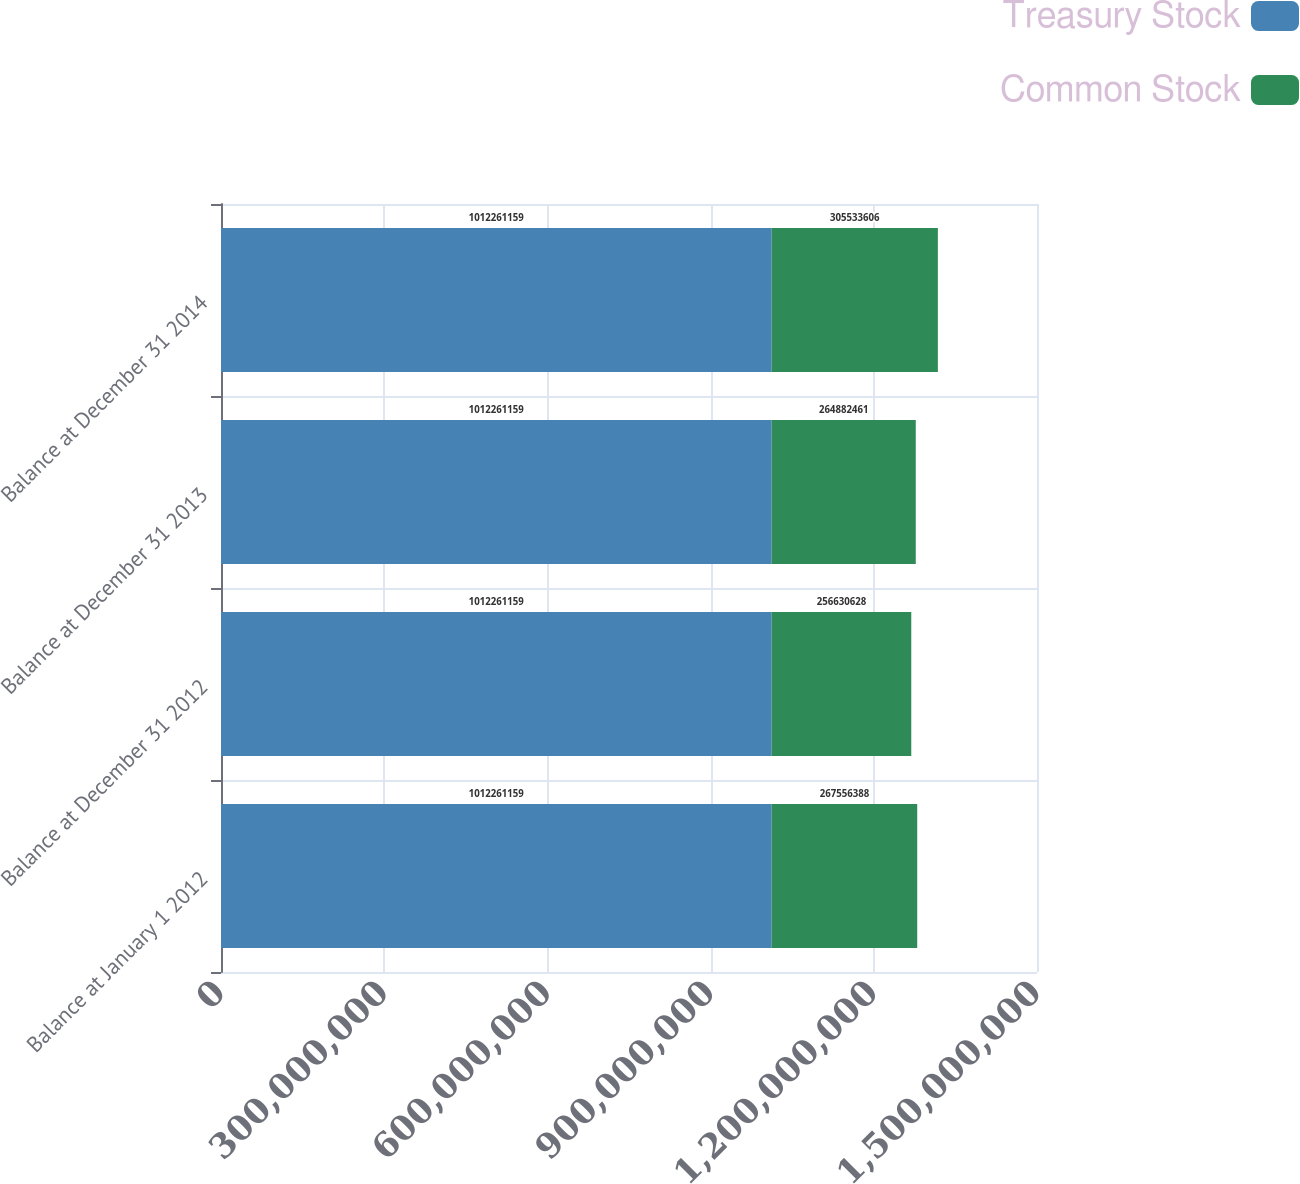Convert chart. <chart><loc_0><loc_0><loc_500><loc_500><stacked_bar_chart><ecel><fcel>Balance at January 1 2012<fcel>Balance at December 31 2012<fcel>Balance at December 31 2013<fcel>Balance at December 31 2014<nl><fcel>Treasury Stock<fcel>1.01226e+09<fcel>1.01226e+09<fcel>1.01226e+09<fcel>1.01226e+09<nl><fcel>Common Stock<fcel>2.67556e+08<fcel>2.56631e+08<fcel>2.64882e+08<fcel>3.05534e+08<nl></chart> 